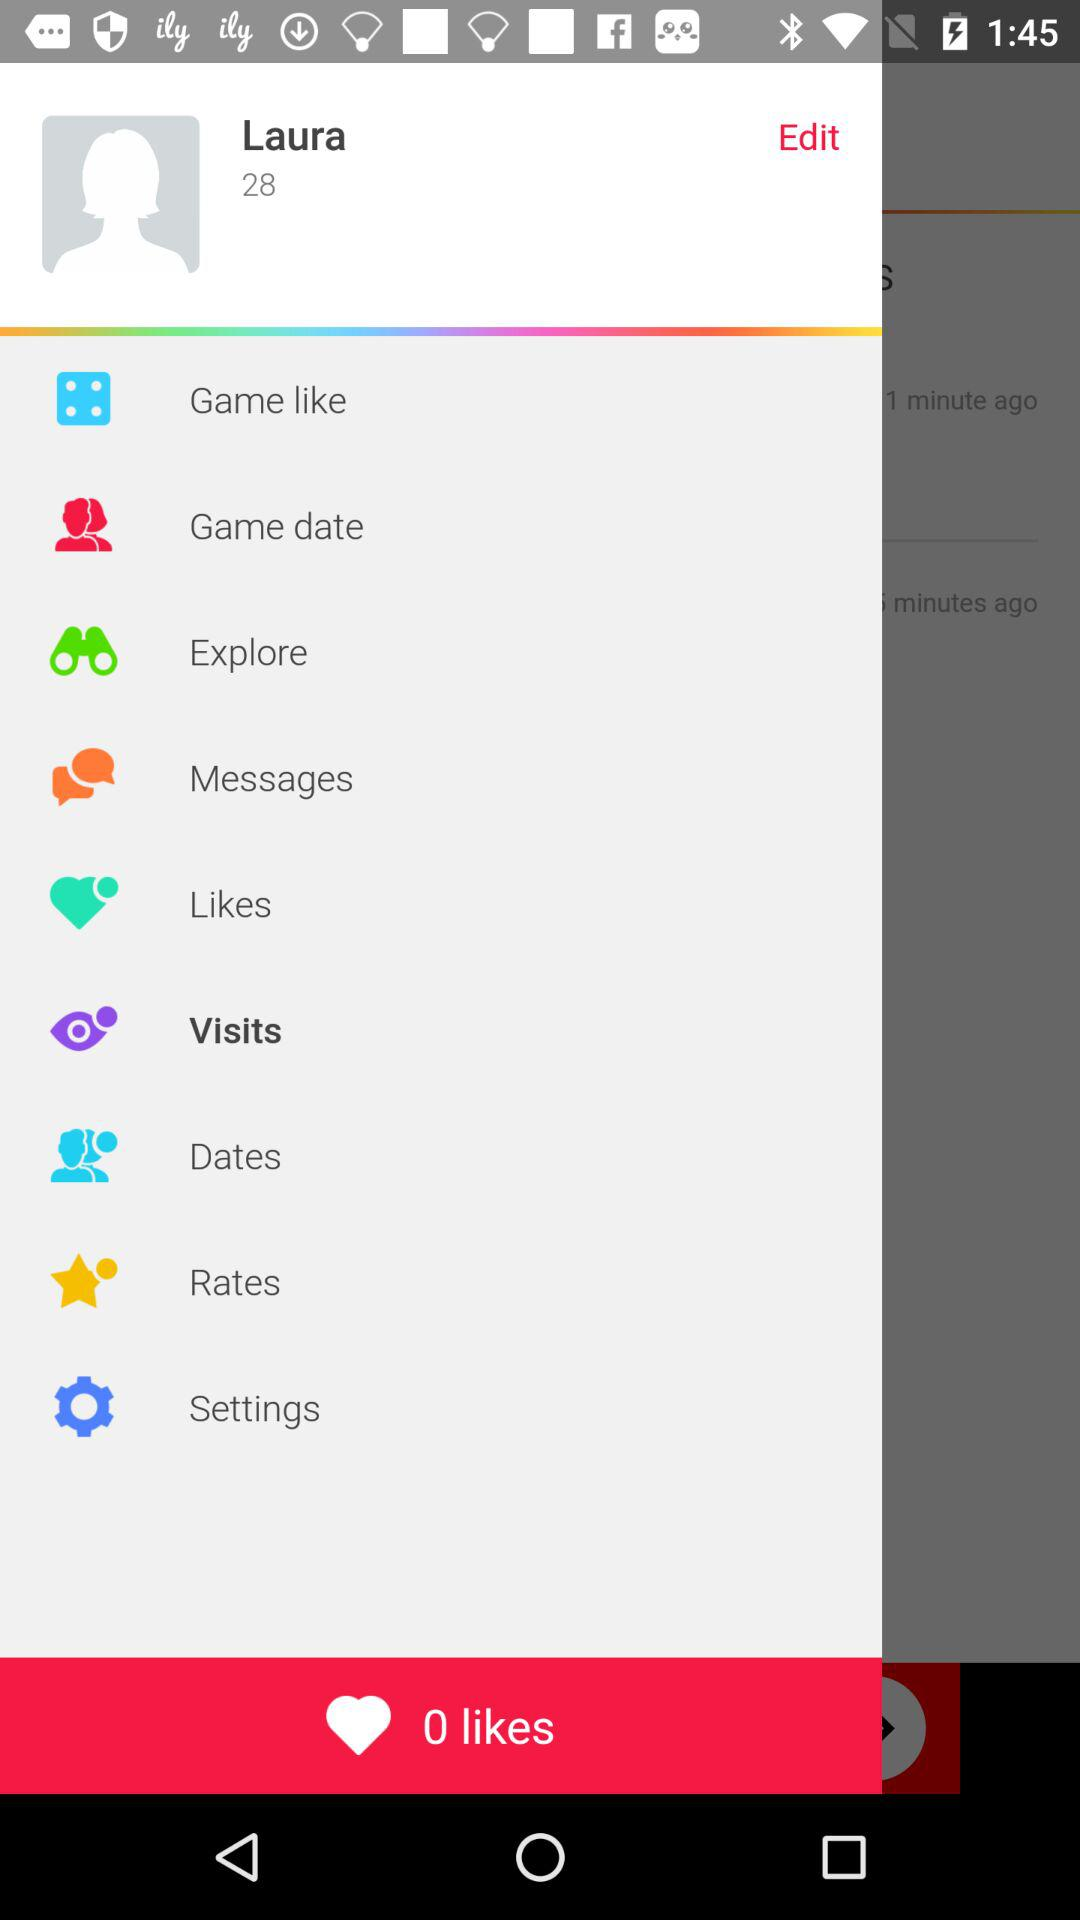What is the age of the user? The user is 28 years old. 